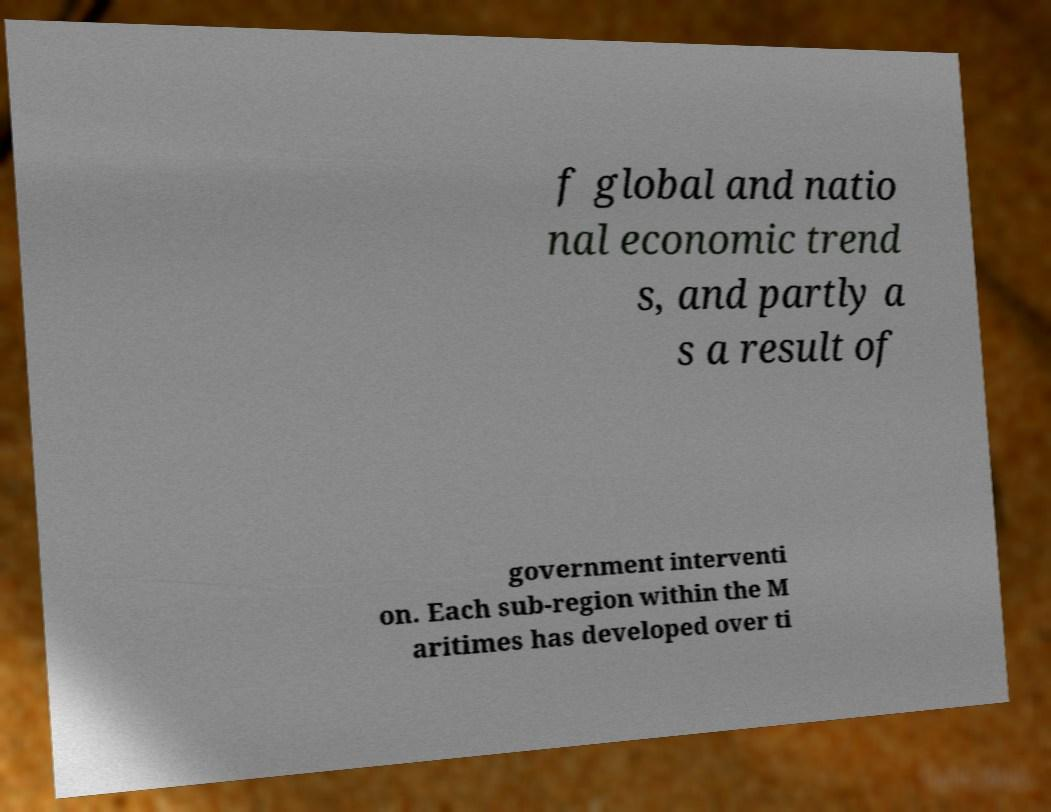Could you assist in decoding the text presented in this image and type it out clearly? f global and natio nal economic trend s, and partly a s a result of government interventi on. Each sub-region within the M aritimes has developed over ti 